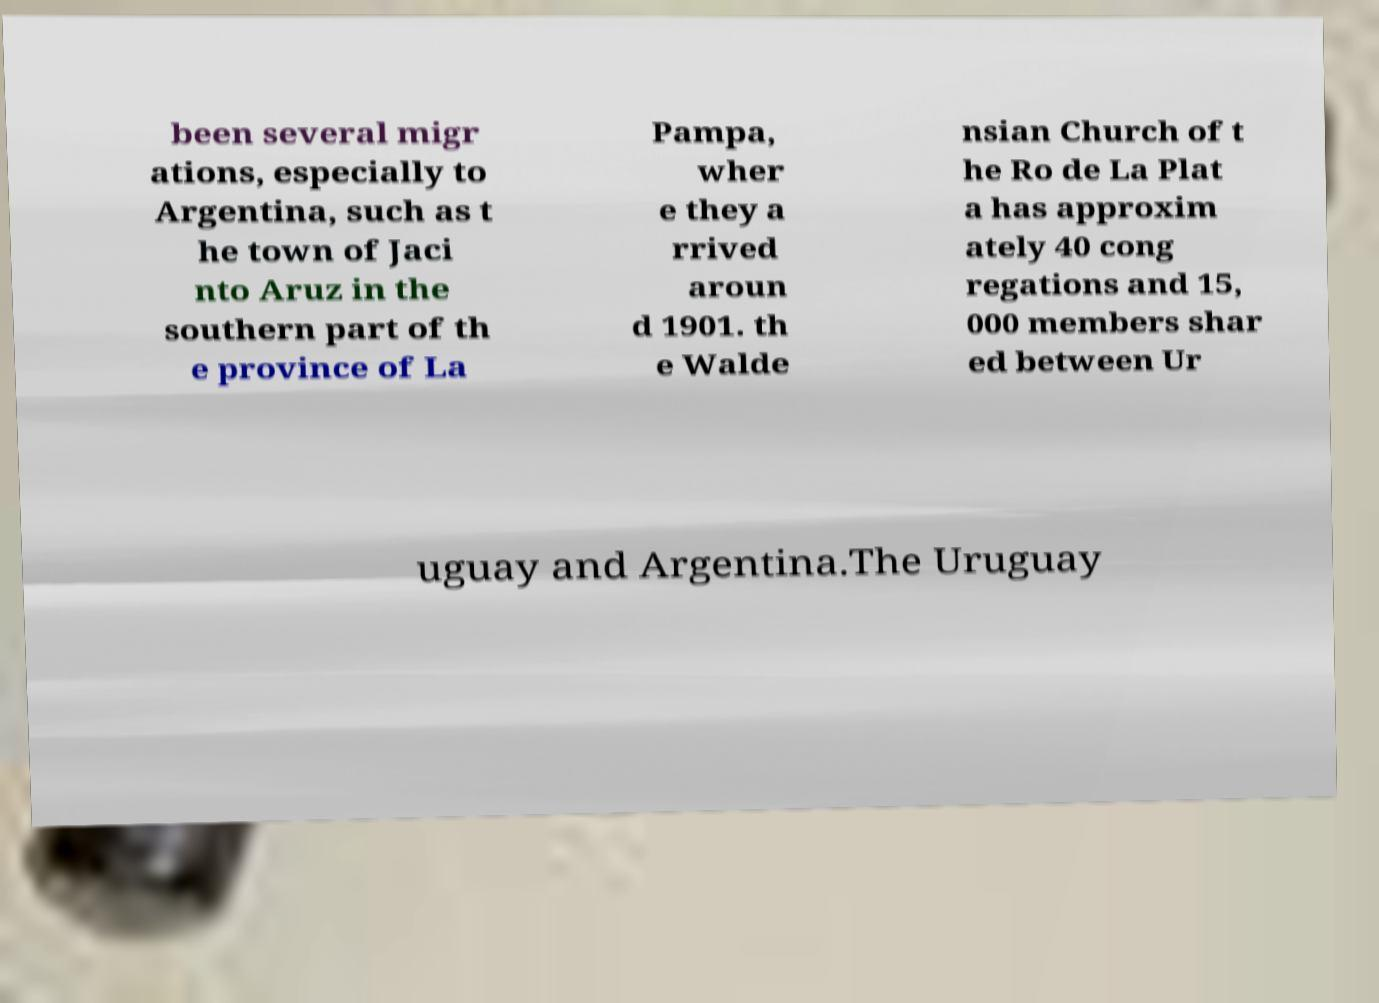Can you accurately transcribe the text from the provided image for me? been several migr ations, especially to Argentina, such as t he town of Jaci nto Aruz in the southern part of th e province of La Pampa, wher e they a rrived aroun d 1901. th e Walde nsian Church of t he Ro de La Plat a has approxim ately 40 cong regations and 15, 000 members shar ed between Ur uguay and Argentina.The Uruguay 